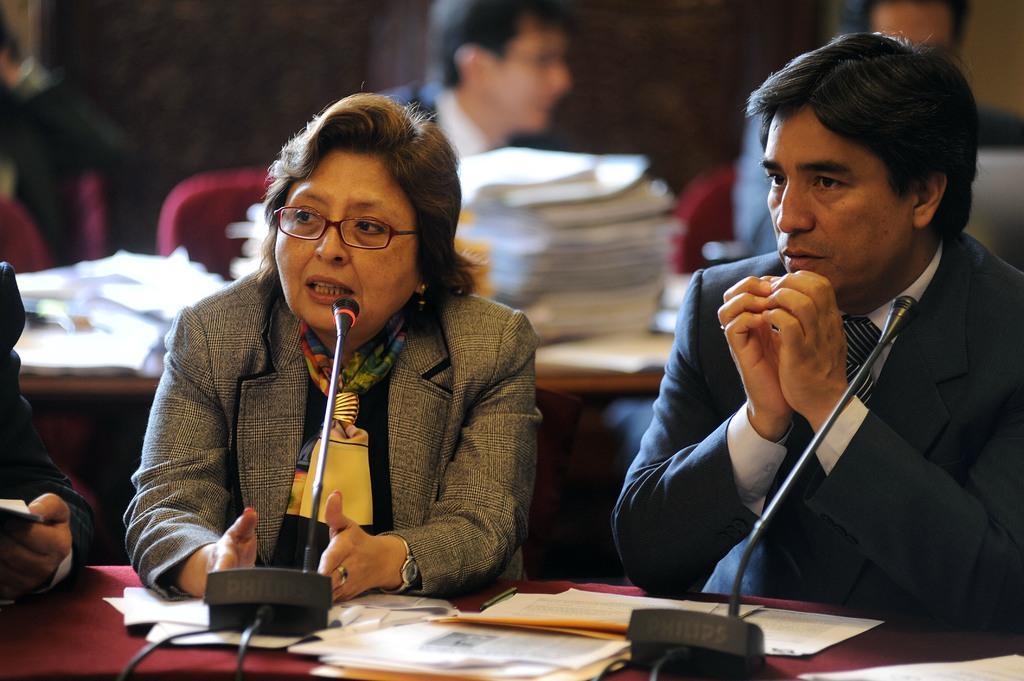Describe this image in one or two sentences. In front of the picture, we see a man and the women are sitting on the chairs. The woman is talking on the microphone. In front of them, we see a table on which the papers, books and microphones are placed. Behind them, we see a table on which the papers and books are placed. Behind that, we see two men are sitting on the chairs. In the background, we see a wall. On the left side, we see two men are sitting on the chairs. This picture is blurred in the background. 